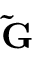<formula> <loc_0><loc_0><loc_500><loc_500>\tilde { G }</formula> 